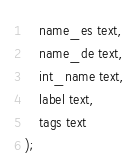Convert code to text. <code><loc_0><loc_0><loc_500><loc_500><_SQL_>    name_es text,
    name_de text,
    int_name text,
    label text,
    tags text
);
</code> 